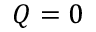<formula> <loc_0><loc_0><loc_500><loc_500>Q = 0</formula> 